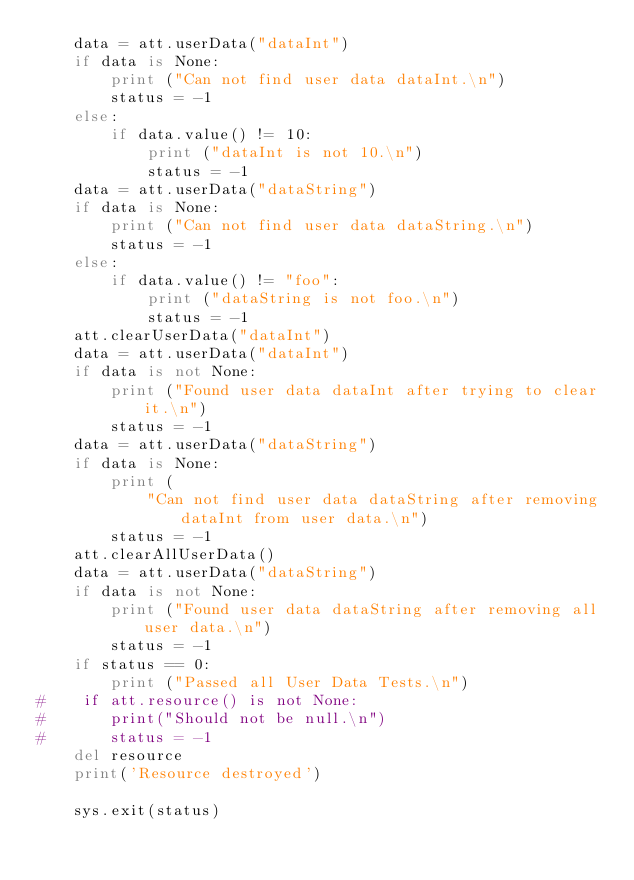<code> <loc_0><loc_0><loc_500><loc_500><_Python_>    data = att.userData("dataInt")
    if data is None:
        print ("Can not find user data dataInt.\n")
        status = -1
    else:
        if data.value() != 10:
            print ("dataInt is not 10.\n")
            status = -1
    data = att.userData("dataString")
    if data is None:
        print ("Can not find user data dataString.\n")
        status = -1
    else:
        if data.value() != "foo":
            print ("dataString is not foo.\n")
            status = -1
    att.clearUserData("dataInt")
    data = att.userData("dataInt")
    if data is not None:
        print ("Found user data dataInt after trying to clear it.\n")
        status = -1
    data = att.userData("dataString")
    if data is None:
        print (
            "Can not find user data dataString after removing dataInt from user data.\n")
        status = -1
    att.clearAllUserData()
    data = att.userData("dataString")
    if data is not None:
        print ("Found user data dataString after removing all user data.\n")
        status = -1
    if status == 0:
        print ("Passed all User Data Tests.\n")
#    if att.resource() is not None:
#       print("Should not be null.\n")
#       status = -1
    del resource
    print('Resource destroyed')

    sys.exit(status)
</code> 